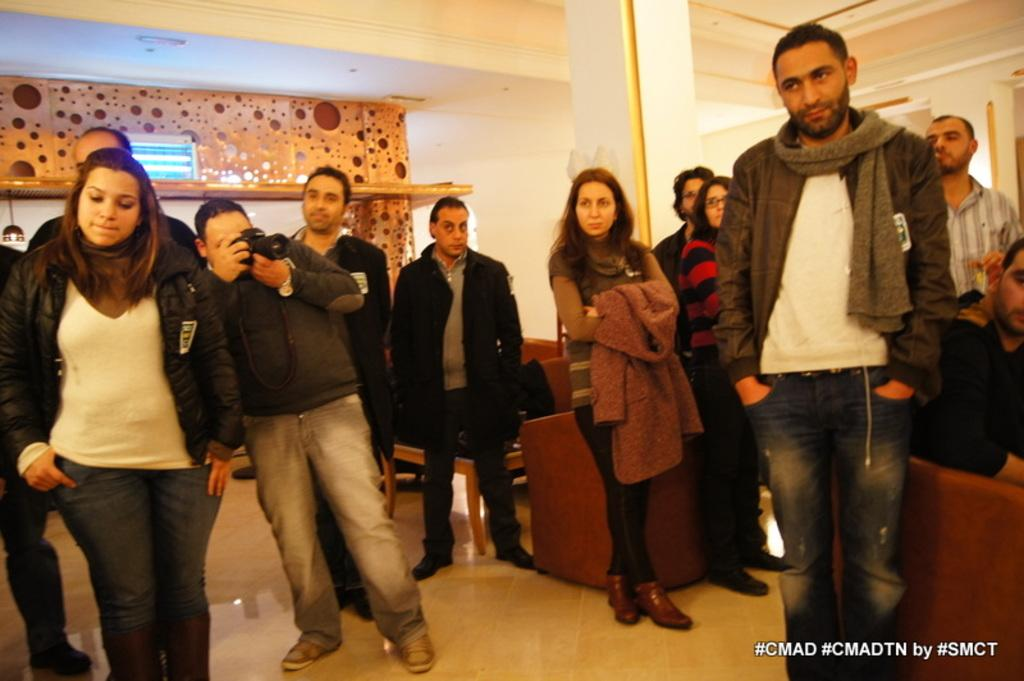Provide a one-sentence caption for the provided image. A group of men and women are gathered in a room with a hashtag of CMAD. 